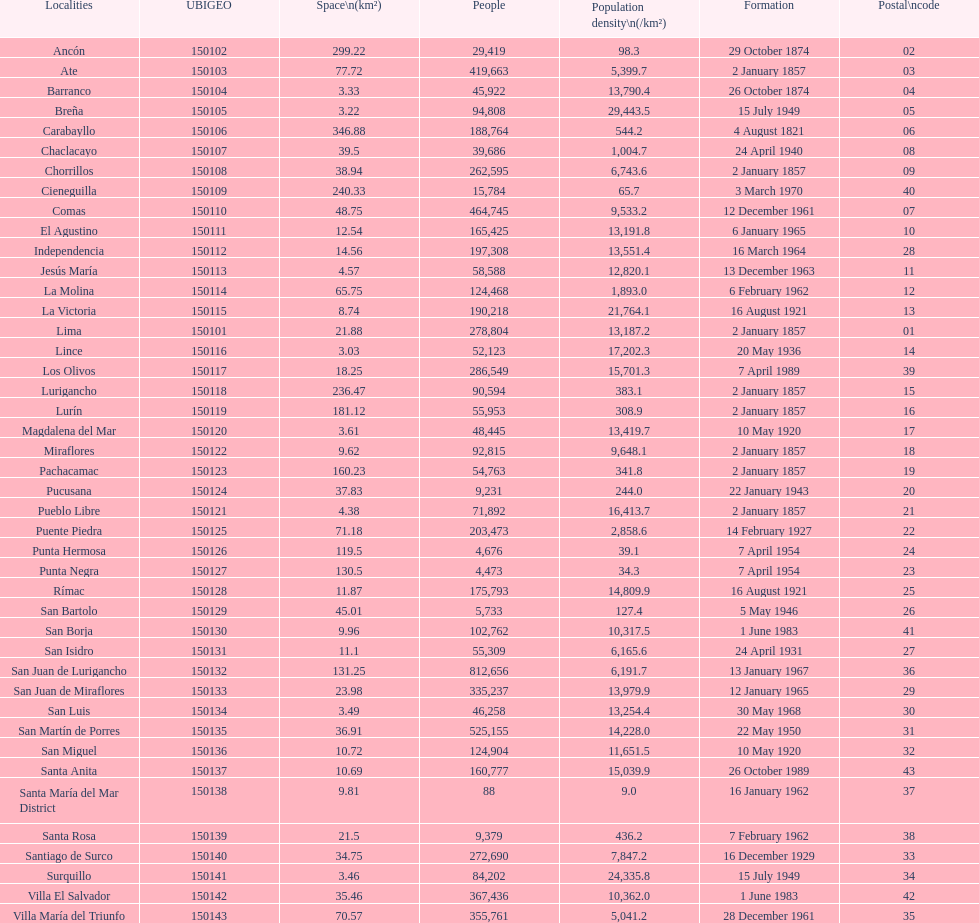How many districts are there in this city? 43. 